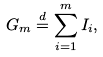Convert formula to latex. <formula><loc_0><loc_0><loc_500><loc_500>G _ { m } \stackrel { d } { = } \sum _ { i = 1 } ^ { m } I _ { i } ,</formula> 